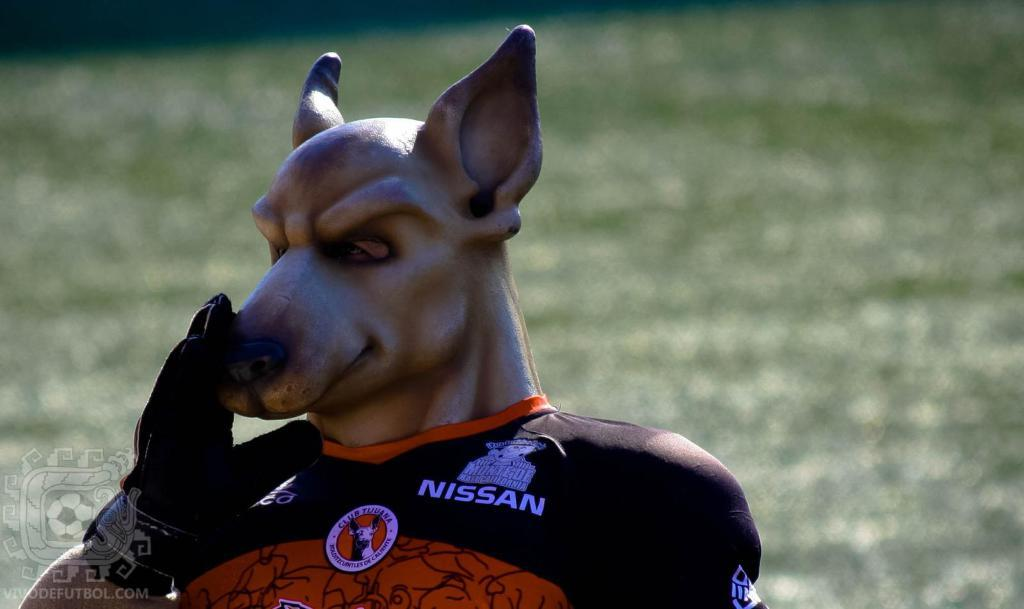What is the main subject of the image? There is a sculpture of an animal in the image. How is the sculpture dressed? The sculpture is dressed with a t-shirt. Can you describe the background of the image? The background of the image is blurred. What type of writing can be seen on the t-shirt of the animal sculpture in the image? There is no writing visible on the t-shirt of the animal sculpture in the image. What kind of pancake is being served next to the sculpture in the image? There is no pancake present in the image; it only features a sculpture of an animal dressed with a t-shirt. 